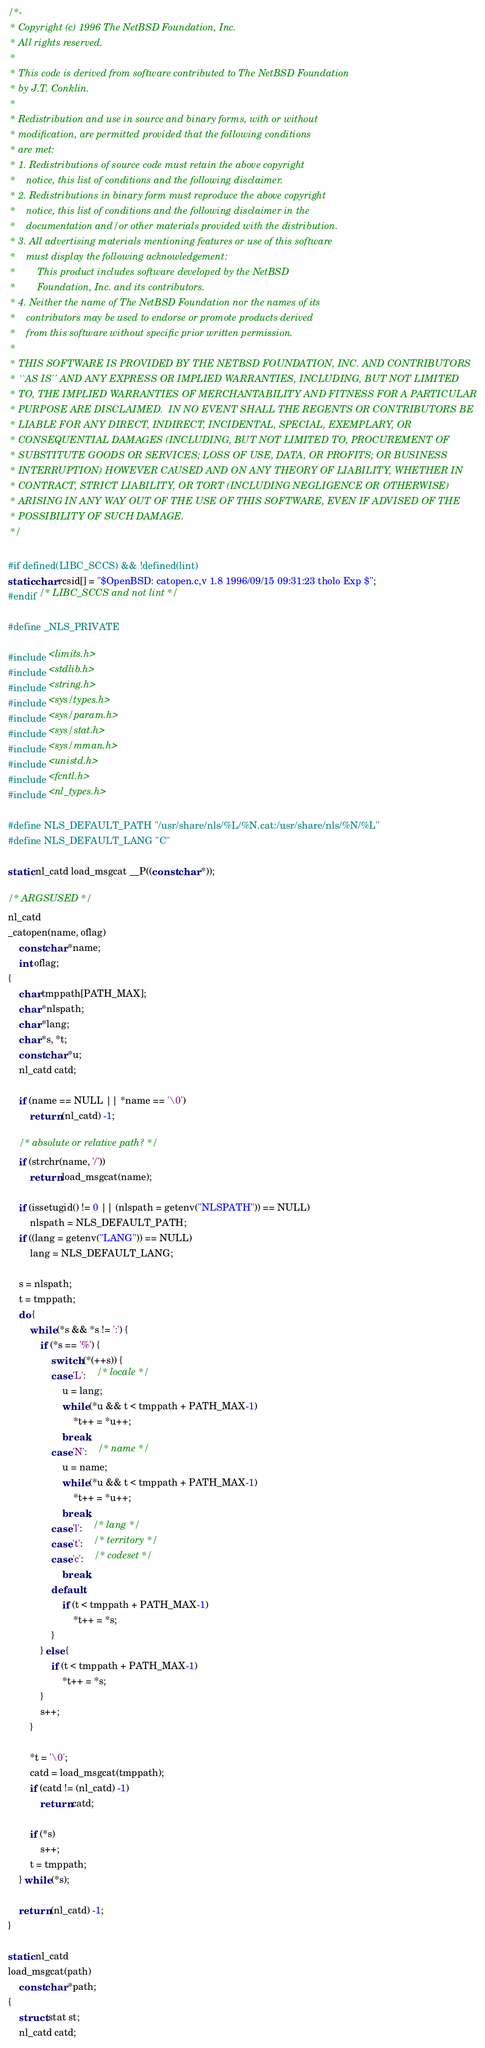<code> <loc_0><loc_0><loc_500><loc_500><_C_>/*-
 * Copyright (c) 1996 The NetBSD Foundation, Inc.
 * All rights reserved.
 *
 * This code is derived from software contributed to The NetBSD Foundation
 * by J.T. Conklin.
 *
 * Redistribution and use in source and binary forms, with or without
 * modification, are permitted provided that the following conditions
 * are met:
 * 1. Redistributions of source code must retain the above copyright
 *    notice, this list of conditions and the following disclaimer.
 * 2. Redistributions in binary form must reproduce the above copyright
 *    notice, this list of conditions and the following disclaimer in the
 *    documentation and/or other materials provided with the distribution.
 * 3. All advertising materials mentioning features or use of this software
 *    must display the following acknowledgement:
 *        This product includes software developed by the NetBSD
 *        Foundation, Inc. and its contributors.
 * 4. Neither the name of The NetBSD Foundation nor the names of its
 *    contributors may be used to endorse or promote products derived
 *    from this software without specific prior written permission.
 *
 * THIS SOFTWARE IS PROVIDED BY THE NETBSD FOUNDATION, INC. AND CONTRIBUTORS
 * ``AS IS'' AND ANY EXPRESS OR IMPLIED WARRANTIES, INCLUDING, BUT NOT LIMITED
 * TO, THE IMPLIED WARRANTIES OF MERCHANTABILITY AND FITNESS FOR A PARTICULAR
 * PURPOSE ARE DISCLAIMED.  IN NO EVENT SHALL THE REGENTS OR CONTRIBUTORS BE
 * LIABLE FOR ANY DIRECT, INDIRECT, INCIDENTAL, SPECIAL, EXEMPLARY, OR
 * CONSEQUENTIAL DAMAGES (INCLUDING, BUT NOT LIMITED TO, PROCUREMENT OF
 * SUBSTITUTE GOODS OR SERVICES; LOSS OF USE, DATA, OR PROFITS; OR BUSINESS
 * INTERRUPTION) HOWEVER CAUSED AND ON ANY THEORY OF LIABILITY, WHETHER IN
 * CONTRACT, STRICT LIABILITY, OR TORT (INCLUDING NEGLIGENCE OR OTHERWISE)
 * ARISING IN ANY WAY OUT OF THE USE OF THIS SOFTWARE, EVEN IF ADVISED OF THE
 * POSSIBILITY OF SUCH DAMAGE.
 */

#if defined(LIBC_SCCS) && !defined(lint)
static char rcsid[] = "$OpenBSD: catopen.c,v 1.8 1996/09/15 09:31:23 tholo Exp $";
#endif /* LIBC_SCCS and not lint */

#define _NLS_PRIVATE

#include <limits.h>
#include <stdlib.h>
#include <string.h>
#include <sys/types.h>
#include <sys/param.h>
#include <sys/stat.h>
#include <sys/mman.h>
#include <unistd.h>
#include <fcntl.h>
#include <nl_types.h>

#define NLS_DEFAULT_PATH "/usr/share/nls/%L/%N.cat:/usr/share/nls/%N/%L"
#define NLS_DEFAULT_LANG "C"

static nl_catd load_msgcat __P((const char *));

/* ARGSUSED */
nl_catd
_catopen(name, oflag)
	const char *name;
	int oflag;
{
	char tmppath[PATH_MAX];
	char *nlspath;
	char *lang;
	char *s, *t;
	const char *u;
	nl_catd catd;
		
	if (name == NULL || *name == '\0')
		return (nl_catd) -1;

	/* absolute or relative path? */
	if (strchr(name, '/'))
		return load_msgcat(name);

	if (issetugid() != 0 || (nlspath = getenv("NLSPATH")) == NULL)
		nlspath = NLS_DEFAULT_PATH;
	if ((lang = getenv("LANG")) == NULL)
		lang = NLS_DEFAULT_LANG;

	s = nlspath;
	t = tmppath;	
	do {
		while (*s && *s != ':') {
			if (*s == '%') {
				switch (*(++s)) {
				case 'L':	/* locale */
					u = lang;
					while (*u && t < tmppath + PATH_MAX-1)
						*t++ = *u++;
					break;
				case 'N':	/* name */
					u = name;
					while (*u && t < tmppath + PATH_MAX-1)
						*t++ = *u++;
					break;
				case 'l':	/* lang */
				case 't':	/* territory */
				case 'c':	/* codeset */
					break;
				default:
					if (t < tmppath + PATH_MAX-1)
						*t++ = *s;
				}
			} else {
				if (t < tmppath + PATH_MAX-1)
					*t++ = *s;
			}
			s++;
		}

		*t = '\0';
		catd = load_msgcat(tmppath);
		if (catd != (nl_catd) -1)
			return catd;

		if (*s)
			s++;
		t = tmppath;
	} while (*s);

	return (nl_catd) -1;
}

static nl_catd
load_msgcat(path)
	const char *path;
{
	struct stat st;
	nl_catd catd;</code> 